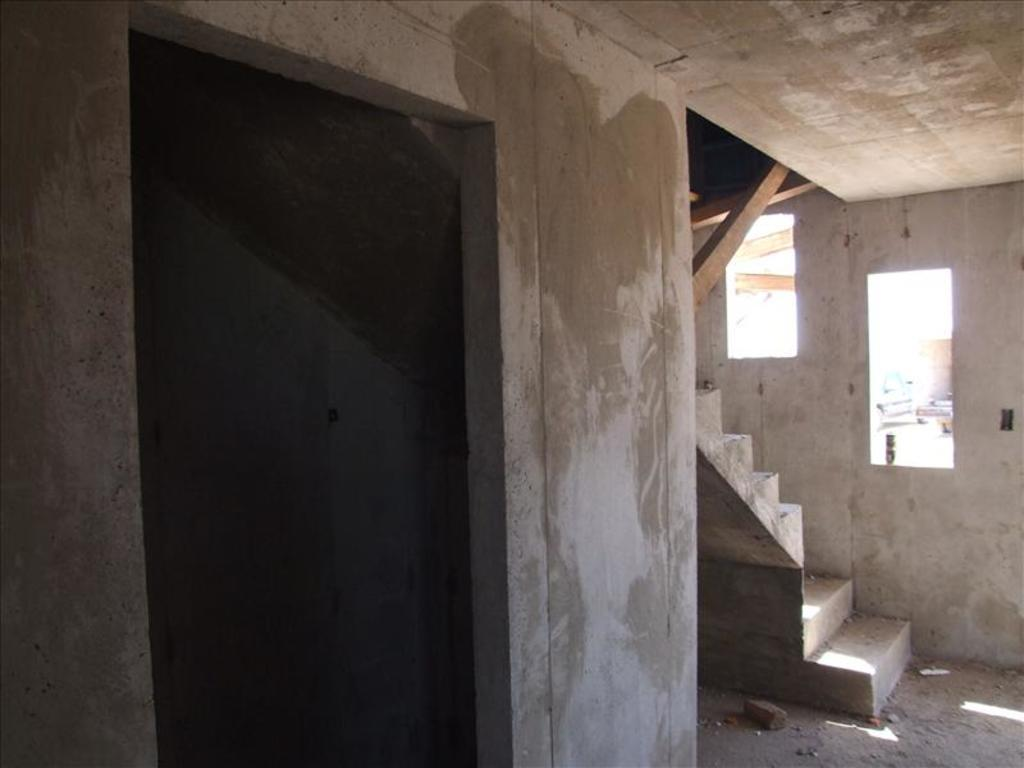What object is placed on the floor in the image? There is a brick on the floor in the image. What architectural feature can be seen in the image? There are steps in the image. What allows natural light to enter the space in the image? There are windows in the image. What surrounds the space in the image? There are walls in the image. What type of location is depicted in the image? The image is an inside view of a building. Where is the maid located in the image? There is no maid present in the image. What type of nest can be seen in the image? There is no nest present in the image. 